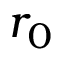Convert formula to latex. <formula><loc_0><loc_0><loc_500><loc_500>r _ { 0 }</formula> 